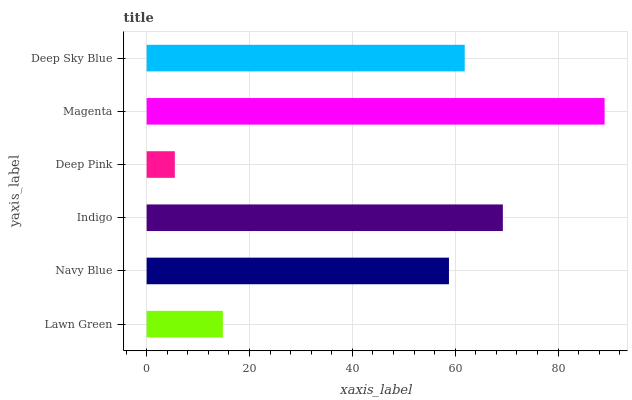Is Deep Pink the minimum?
Answer yes or no. Yes. Is Magenta the maximum?
Answer yes or no. Yes. Is Navy Blue the minimum?
Answer yes or no. No. Is Navy Blue the maximum?
Answer yes or no. No. Is Navy Blue greater than Lawn Green?
Answer yes or no. Yes. Is Lawn Green less than Navy Blue?
Answer yes or no. Yes. Is Lawn Green greater than Navy Blue?
Answer yes or no. No. Is Navy Blue less than Lawn Green?
Answer yes or no. No. Is Deep Sky Blue the high median?
Answer yes or no. Yes. Is Navy Blue the low median?
Answer yes or no. Yes. Is Indigo the high median?
Answer yes or no. No. Is Deep Pink the low median?
Answer yes or no. No. 